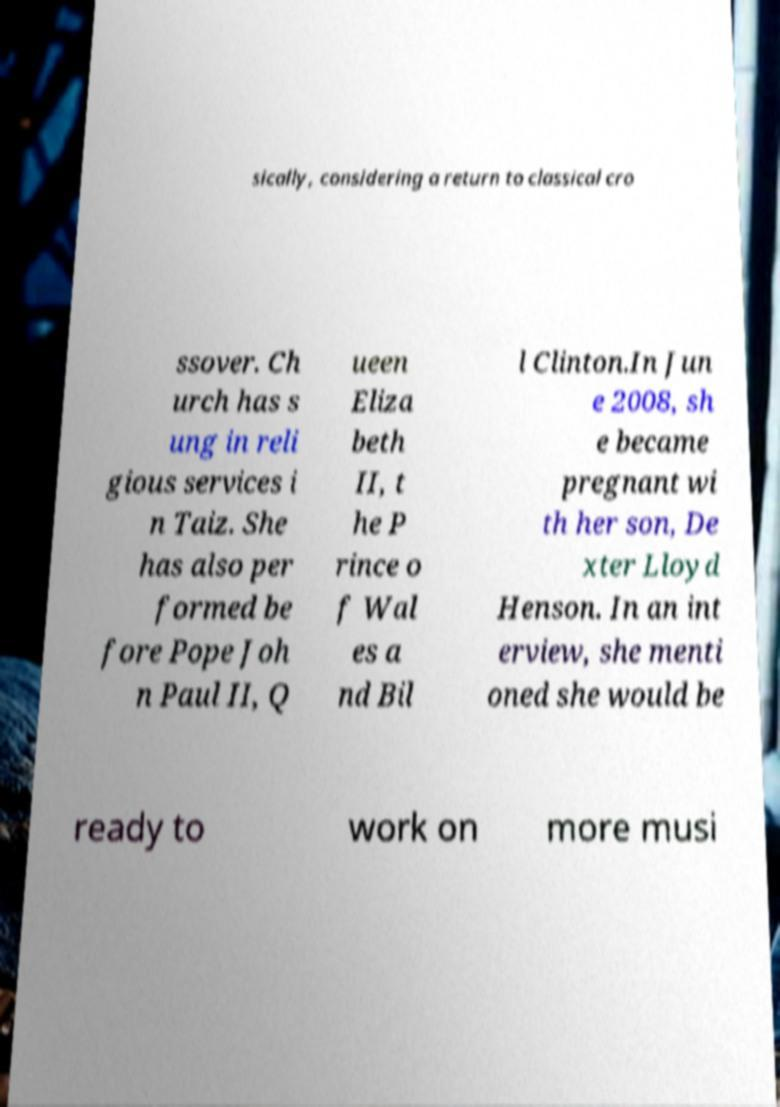Could you assist in decoding the text presented in this image and type it out clearly? sically, considering a return to classical cro ssover. Ch urch has s ung in reli gious services i n Taiz. She has also per formed be fore Pope Joh n Paul II, Q ueen Eliza beth II, t he P rince o f Wal es a nd Bil l Clinton.In Jun e 2008, sh e became pregnant wi th her son, De xter Lloyd Henson. In an int erview, she menti oned she would be ready to work on more musi 